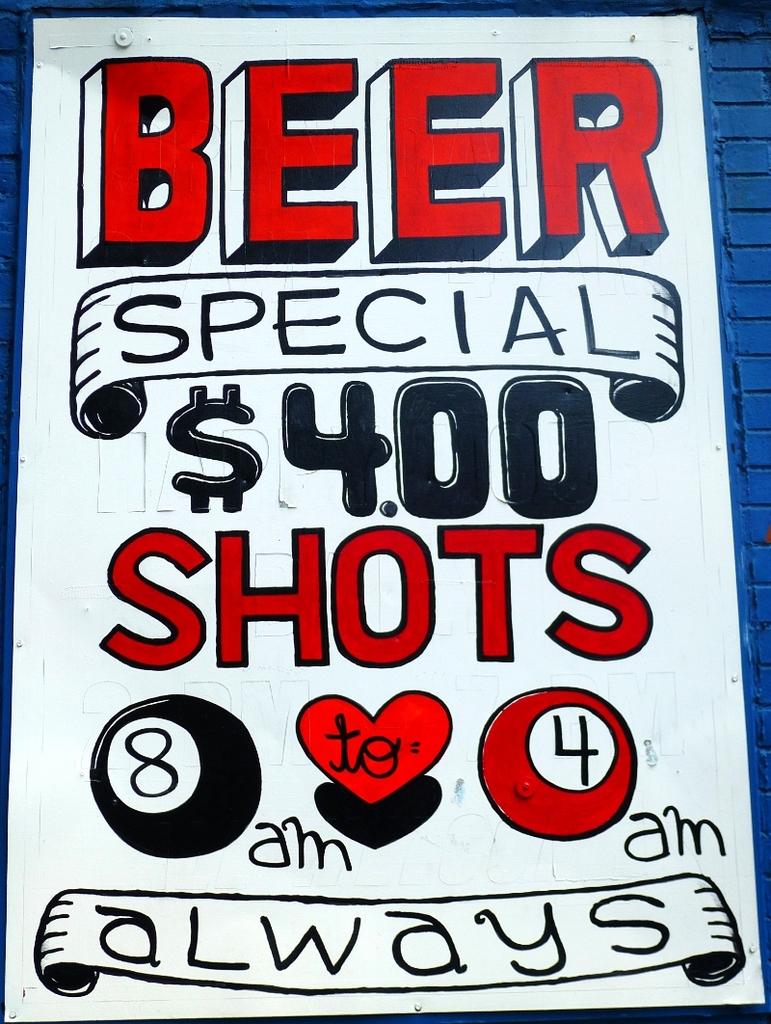How much is the beer special?
Keep it short and to the point. $4.00. What time is the special for?
Make the answer very short. 8am to 4am. 